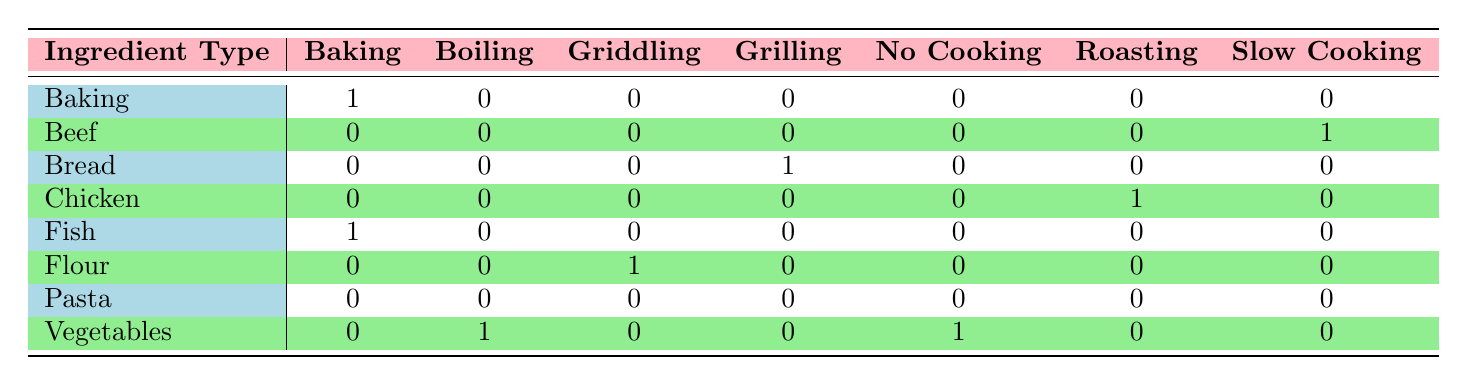What is the cooking method for Beef Stew? Looking at the table, Beef Stew is associated with the ingredient type "Beef," and under the "Slow Cooking" column, there is a count of 1, indicating that it is cooked using this method.
Answer: Slow Cooking How many recipes use Baking as a cooking method? The "Baking" column shows that there are two instances with a count of 1 for both "Baking" and "Fish," indicating that a total of 2 recipes use this cooking method.
Answer: 2 Is there any recipe that requires no cooking? The table shows that in the "No Cooking" column, there is a count of 1 for "Vegetables." This implies that there is indeed a recipe that requires no cooking, specifically Caesar Salad.
Answer: Yes What is the total number of recipes listed for Griddling? In the "Griddling" column, there is a count of 1 for "Flour," which indicates there is only 1 recipe listed under this cooking method.
Answer: 1 Which ingredient type has the most cooking methods associated with it? By examining each row, the count for each ingredient type shows that "Chicken" has two associated cooking methods: "Stir Frying" and "Roasting." Therefore, Chicken is the ingredient type with the most cooking methods.
Answer: Chicken What is the difference in the number of recipes between Baking and Boiling as cooking methods? The "Baking" column shows a count of 2 recipes while the "Boiling" column indicates only 1 recipe (Vegetable Soup). Thus, the difference is 2 - 1 = 1.
Answer: 1 How many ingredients have recipes associated with Grilling? Analyzing the "Grilling" column reveals that only "Bread" has a count of 1, thereby indicating that there is 1 ingredient with a recipe linked to grilling.
Answer: 1 Are there any recipes that utilize both Baking and No Cooking? Examining the Baking and No Cooking columns, there is no overlap or common recipes listed since both columns show different ingredients with respective counts. Thus, the answer is no.
Answer: No What is the total count of recipes grouped under Vegetables? In the ingredient types, we see that "Vegetables" appears under both "Boiling" (1 for Vegetable Soup) and "No Cooking" (1 for Caesar Salad), giving a total of 2 recipes.
Answer: 2 